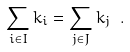Convert formula to latex. <formula><loc_0><loc_0><loc_500><loc_500>\sum _ { i \in I } k _ { i } = \sum _ { j \in J } k _ { j } \ .</formula> 